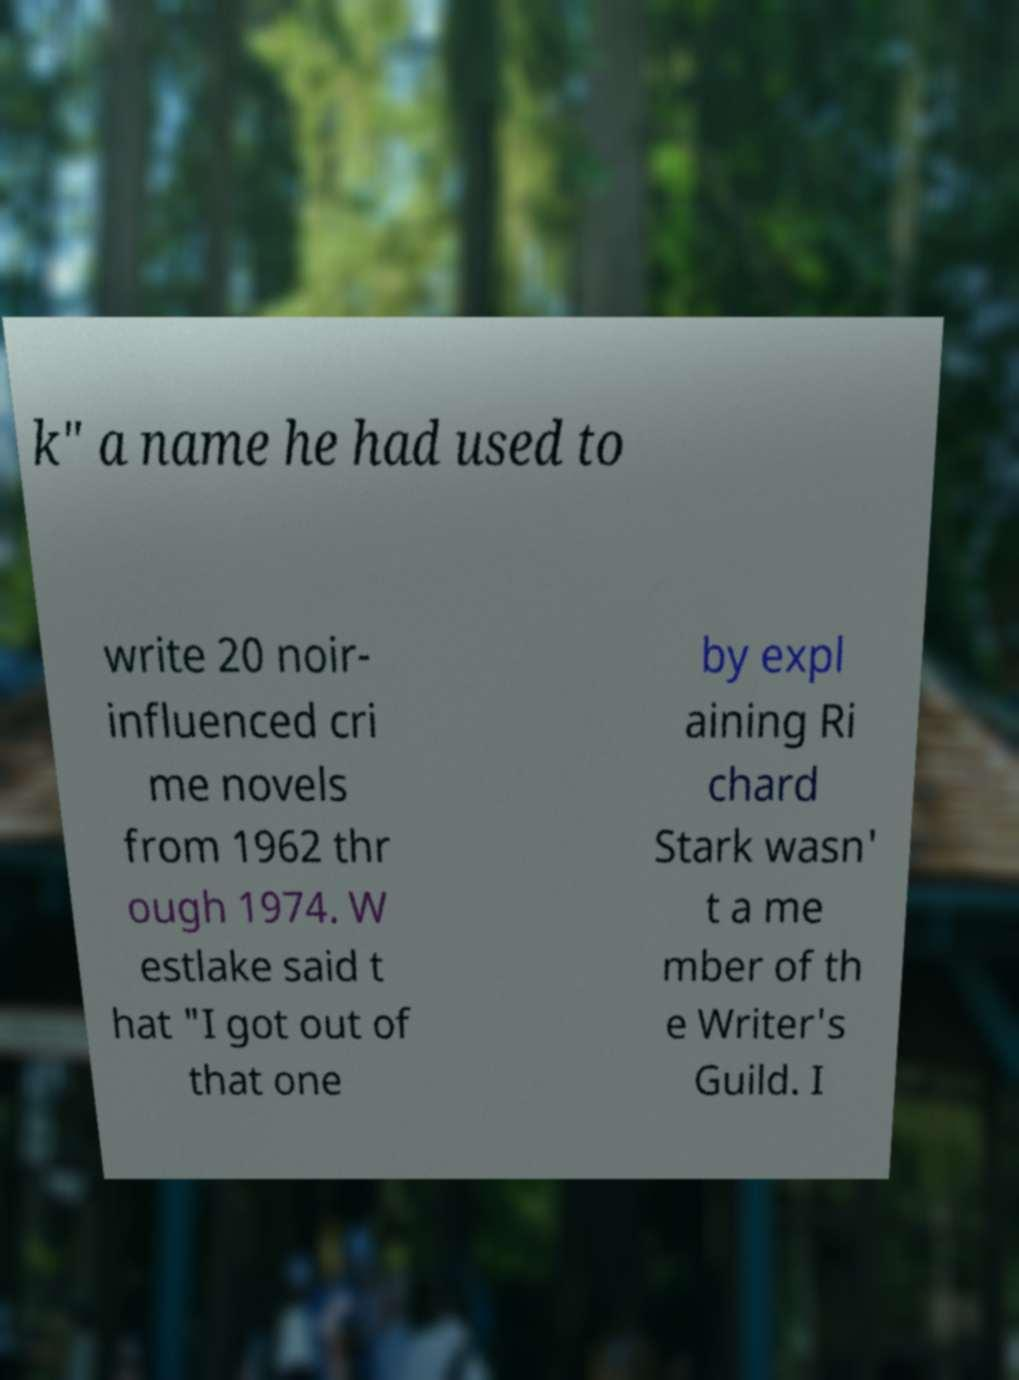I need the written content from this picture converted into text. Can you do that? k" a name he had used to write 20 noir- influenced cri me novels from 1962 thr ough 1974. W estlake said t hat "I got out of that one by expl aining Ri chard Stark wasn' t a me mber of th e Writer's Guild. I 